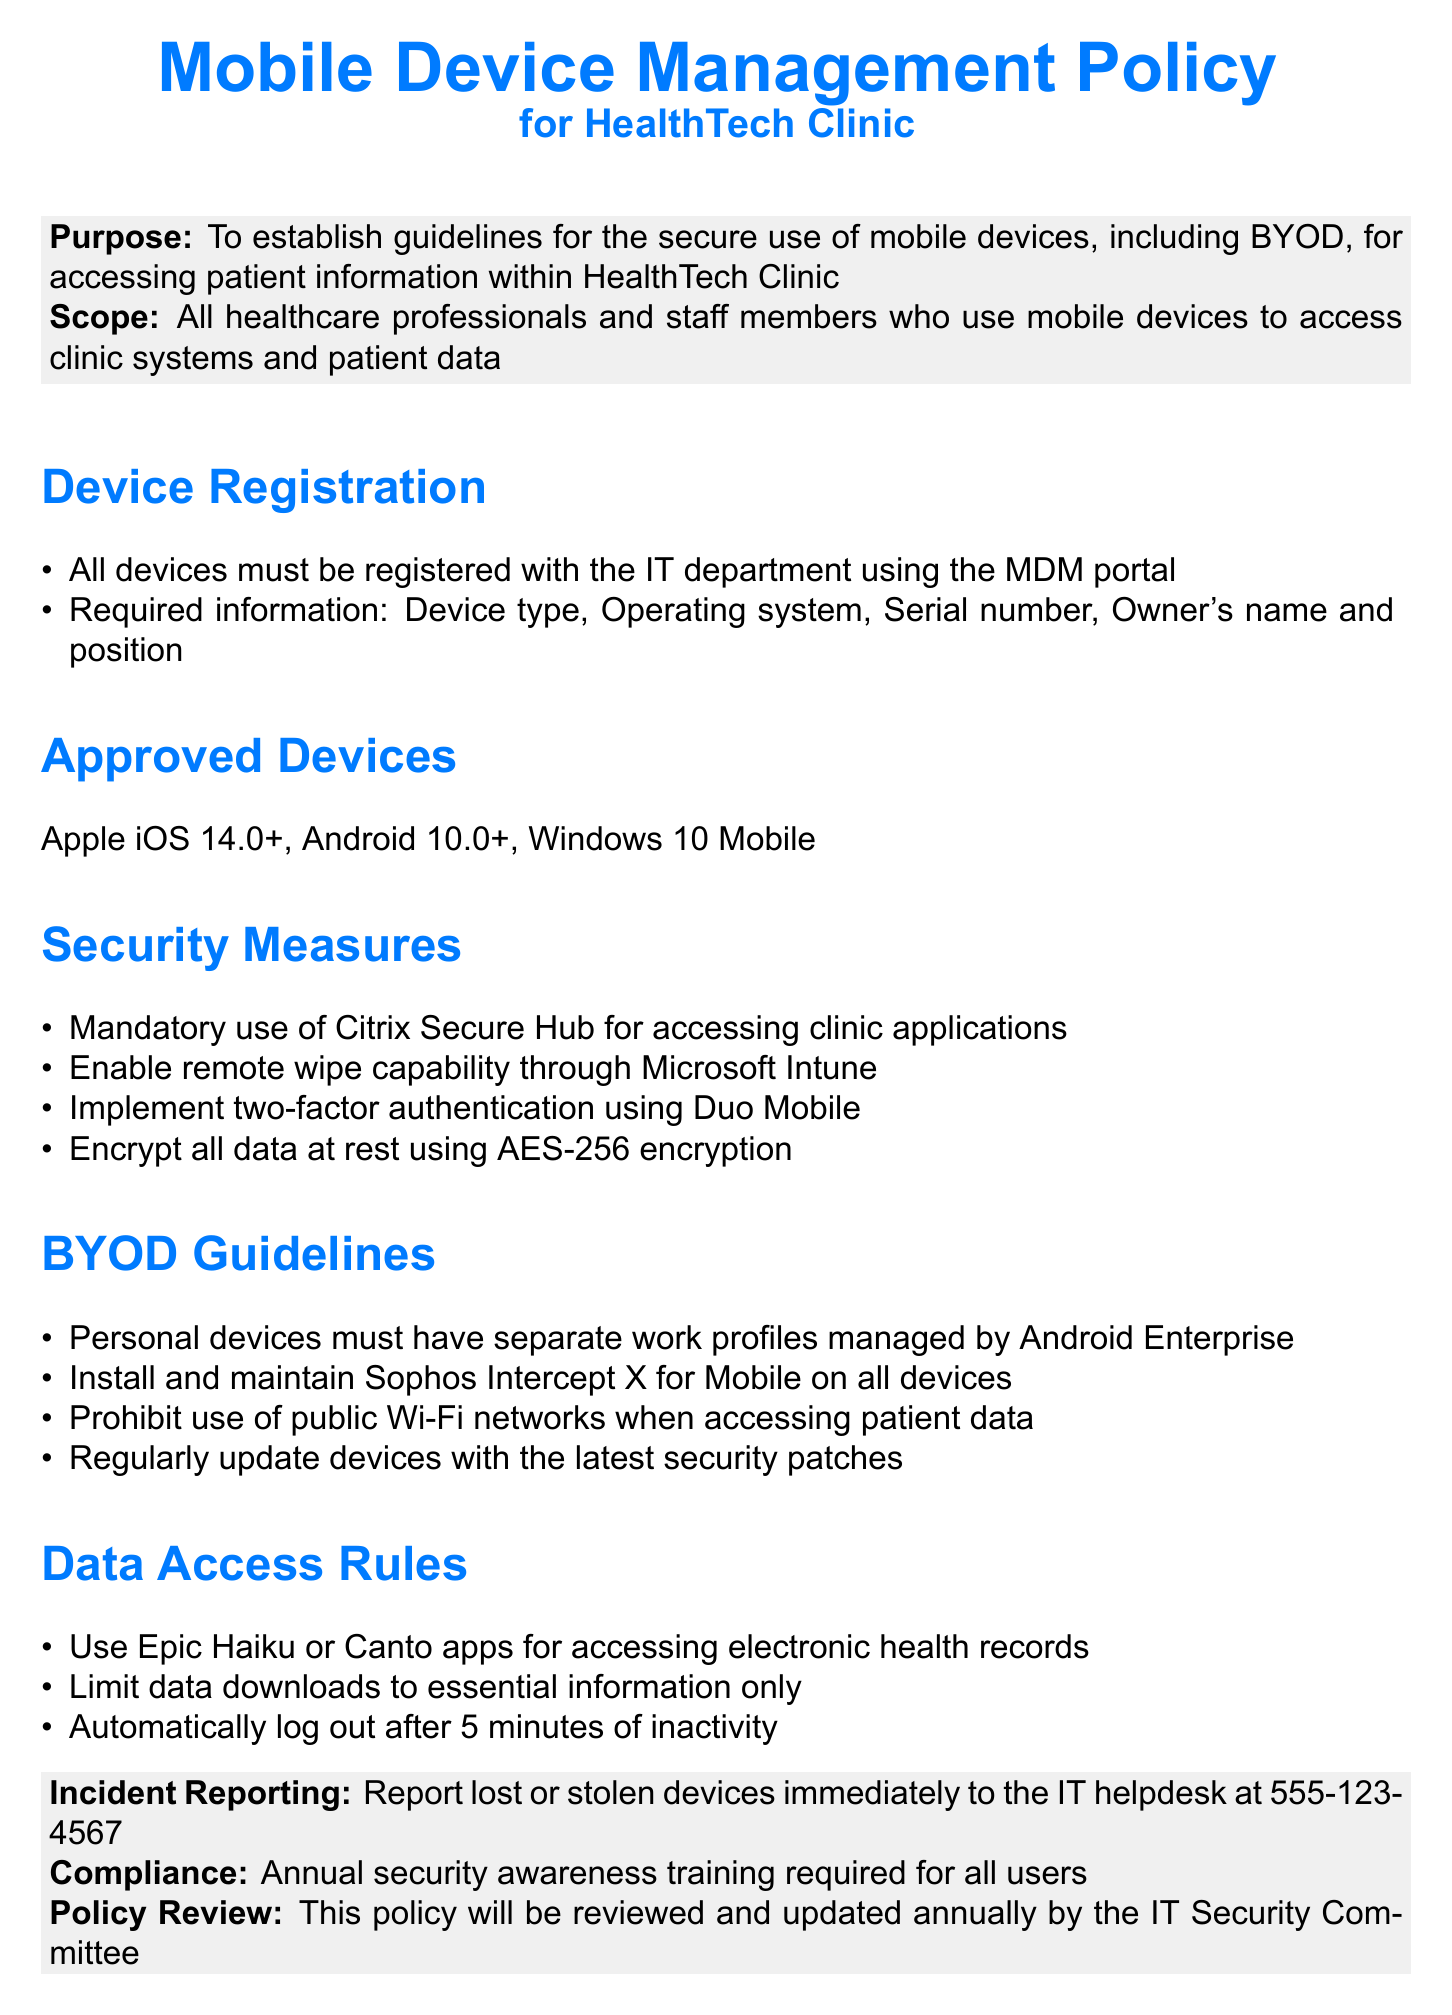What is the purpose of the Mobile Device Management Policy? The purpose is to establish guidelines for the secure use of mobile devices, including BYOD, for accessing patient information within HealthTech Clinic.
Answer: To establish guidelines for the secure use of mobile devices, including BYOD, for accessing patient information within HealthTech Clinic Who must register their devices with the IT department? The scope of the policy covers all healthcare professionals and staff members who use mobile devices to access clinic systems and patient data.
Answer: All healthcare professionals and staff members What operating systems are approved for mobile devices? The document specifies Apple iOS 14.0+, Android 10.0+, and Windows 10 Mobile as the approved operating systems.
Answer: Apple iOS 14.0+, Android 10.0+, Windows 10 Mobile What encryption standard is required for data at rest? The security measures mandate the use of AES-256 encryption for data at rest, thus ensuring data security.
Answer: AES-256 encryption What is the consequence of losing a device? The policy states that lost or stolen devices must be reported immediately to the IT helpdesk.
Answer: Report immediately to the IT helpdesk How often must security awareness training be conducted? The document requires that annual security awareness training is mandatory for all users, ensuring ongoing education about security.
Answer: Annual What application is recommended for accessing electronic health records? The document recommends using the Epic Haiku or Canto apps for accessing electronic health records.
Answer: Epic Haiku or Canto apps What is the required action after 5 minutes of inactivity? The policy mandates users to automatically log out after 5 minutes of inactivity to enhance security protocols.
Answer: Automatically log out 